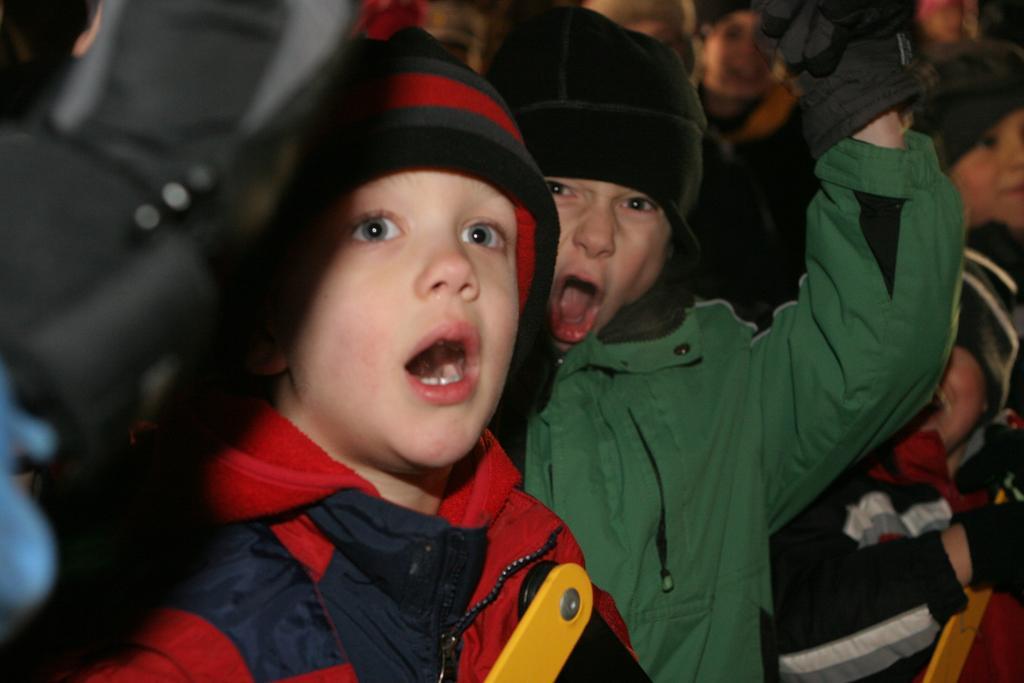How would you summarize this image in a sentence or two? In this image we can see kids wearing caps. 